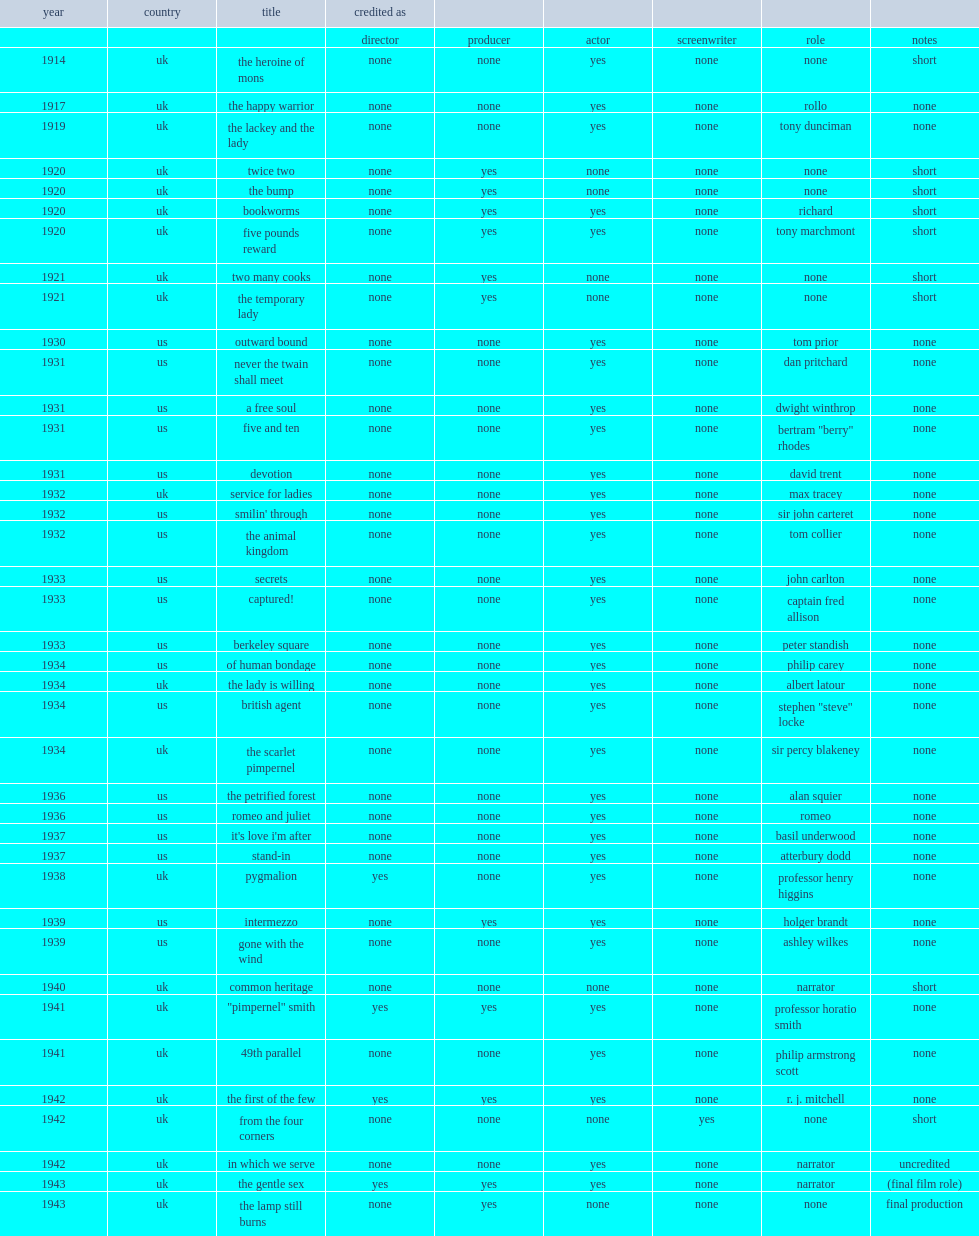What was the role that howard acted in gone with the wind (1939)? Ashley wilkes. 